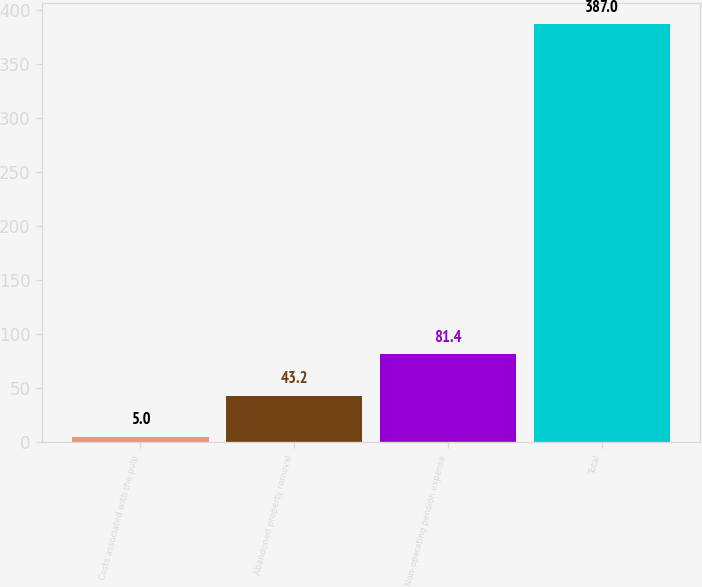Convert chart. <chart><loc_0><loc_0><loc_500><loc_500><bar_chart><fcel>Costs associated with the pulp<fcel>Abandoned property removal<fcel>Non-operating pension expense<fcel>Total<nl><fcel>5<fcel>43.2<fcel>81.4<fcel>387<nl></chart> 